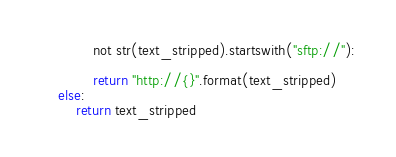Convert code to text. <code><loc_0><loc_0><loc_500><loc_500><_Python_>            not str(text_stripped).startswith("sftp://"):

            return "http://{}".format(text_stripped)
    else:
        return text_stripped</code> 